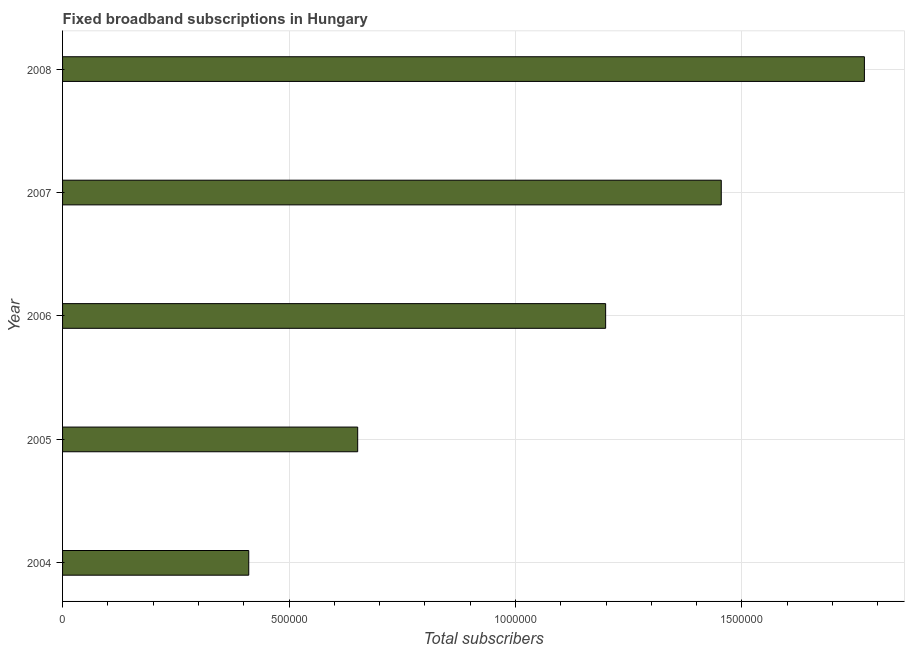Does the graph contain any zero values?
Your answer should be compact. No. What is the title of the graph?
Give a very brief answer. Fixed broadband subscriptions in Hungary. What is the label or title of the X-axis?
Ensure brevity in your answer.  Total subscribers. What is the label or title of the Y-axis?
Make the answer very short. Year. What is the total number of fixed broadband subscriptions in 2006?
Keep it short and to the point. 1.20e+06. Across all years, what is the maximum total number of fixed broadband subscriptions?
Your answer should be compact. 1.77e+06. Across all years, what is the minimum total number of fixed broadband subscriptions?
Offer a terse response. 4.11e+05. In which year was the total number of fixed broadband subscriptions maximum?
Your answer should be very brief. 2008. What is the sum of the total number of fixed broadband subscriptions?
Ensure brevity in your answer.  5.49e+06. What is the difference between the total number of fixed broadband subscriptions in 2007 and 2008?
Your answer should be very brief. -3.16e+05. What is the average total number of fixed broadband subscriptions per year?
Provide a succinct answer. 1.10e+06. What is the median total number of fixed broadband subscriptions?
Provide a succinct answer. 1.20e+06. In how many years, is the total number of fixed broadband subscriptions greater than 500000 ?
Your answer should be very brief. 4. Do a majority of the years between 2008 and 2006 (inclusive) have total number of fixed broadband subscriptions greater than 1200000 ?
Your answer should be very brief. Yes. What is the ratio of the total number of fixed broadband subscriptions in 2004 to that in 2006?
Your answer should be very brief. 0.34. Is the total number of fixed broadband subscriptions in 2005 less than that in 2008?
Offer a very short reply. Yes. What is the difference between the highest and the second highest total number of fixed broadband subscriptions?
Make the answer very short. 3.16e+05. What is the difference between the highest and the lowest total number of fixed broadband subscriptions?
Provide a succinct answer. 1.36e+06. In how many years, is the total number of fixed broadband subscriptions greater than the average total number of fixed broadband subscriptions taken over all years?
Give a very brief answer. 3. How many bars are there?
Your answer should be very brief. 5. How many years are there in the graph?
Offer a terse response. 5. What is the Total subscribers of 2004?
Your response must be concise. 4.11e+05. What is the Total subscribers of 2005?
Offer a very short reply. 6.52e+05. What is the Total subscribers of 2006?
Make the answer very short. 1.20e+06. What is the Total subscribers in 2007?
Keep it short and to the point. 1.45e+06. What is the Total subscribers in 2008?
Your response must be concise. 1.77e+06. What is the difference between the Total subscribers in 2004 and 2005?
Give a very brief answer. -2.41e+05. What is the difference between the Total subscribers in 2004 and 2006?
Offer a terse response. -7.88e+05. What is the difference between the Total subscribers in 2004 and 2007?
Offer a very short reply. -1.04e+06. What is the difference between the Total subscribers in 2004 and 2008?
Keep it short and to the point. -1.36e+06. What is the difference between the Total subscribers in 2005 and 2006?
Your response must be concise. -5.48e+05. What is the difference between the Total subscribers in 2005 and 2007?
Offer a terse response. -8.03e+05. What is the difference between the Total subscribers in 2005 and 2008?
Your answer should be compact. -1.12e+06. What is the difference between the Total subscribers in 2006 and 2007?
Your answer should be compact. -2.55e+05. What is the difference between the Total subscribers in 2006 and 2008?
Your answer should be compact. -5.71e+05. What is the difference between the Total subscribers in 2007 and 2008?
Keep it short and to the point. -3.16e+05. What is the ratio of the Total subscribers in 2004 to that in 2005?
Make the answer very short. 0.63. What is the ratio of the Total subscribers in 2004 to that in 2006?
Your response must be concise. 0.34. What is the ratio of the Total subscribers in 2004 to that in 2007?
Provide a succinct answer. 0.28. What is the ratio of the Total subscribers in 2004 to that in 2008?
Your answer should be compact. 0.23. What is the ratio of the Total subscribers in 2005 to that in 2006?
Make the answer very short. 0.54. What is the ratio of the Total subscribers in 2005 to that in 2007?
Offer a terse response. 0.45. What is the ratio of the Total subscribers in 2005 to that in 2008?
Provide a short and direct response. 0.37. What is the ratio of the Total subscribers in 2006 to that in 2007?
Your answer should be very brief. 0.82. What is the ratio of the Total subscribers in 2006 to that in 2008?
Your answer should be very brief. 0.68. What is the ratio of the Total subscribers in 2007 to that in 2008?
Provide a succinct answer. 0.82. 